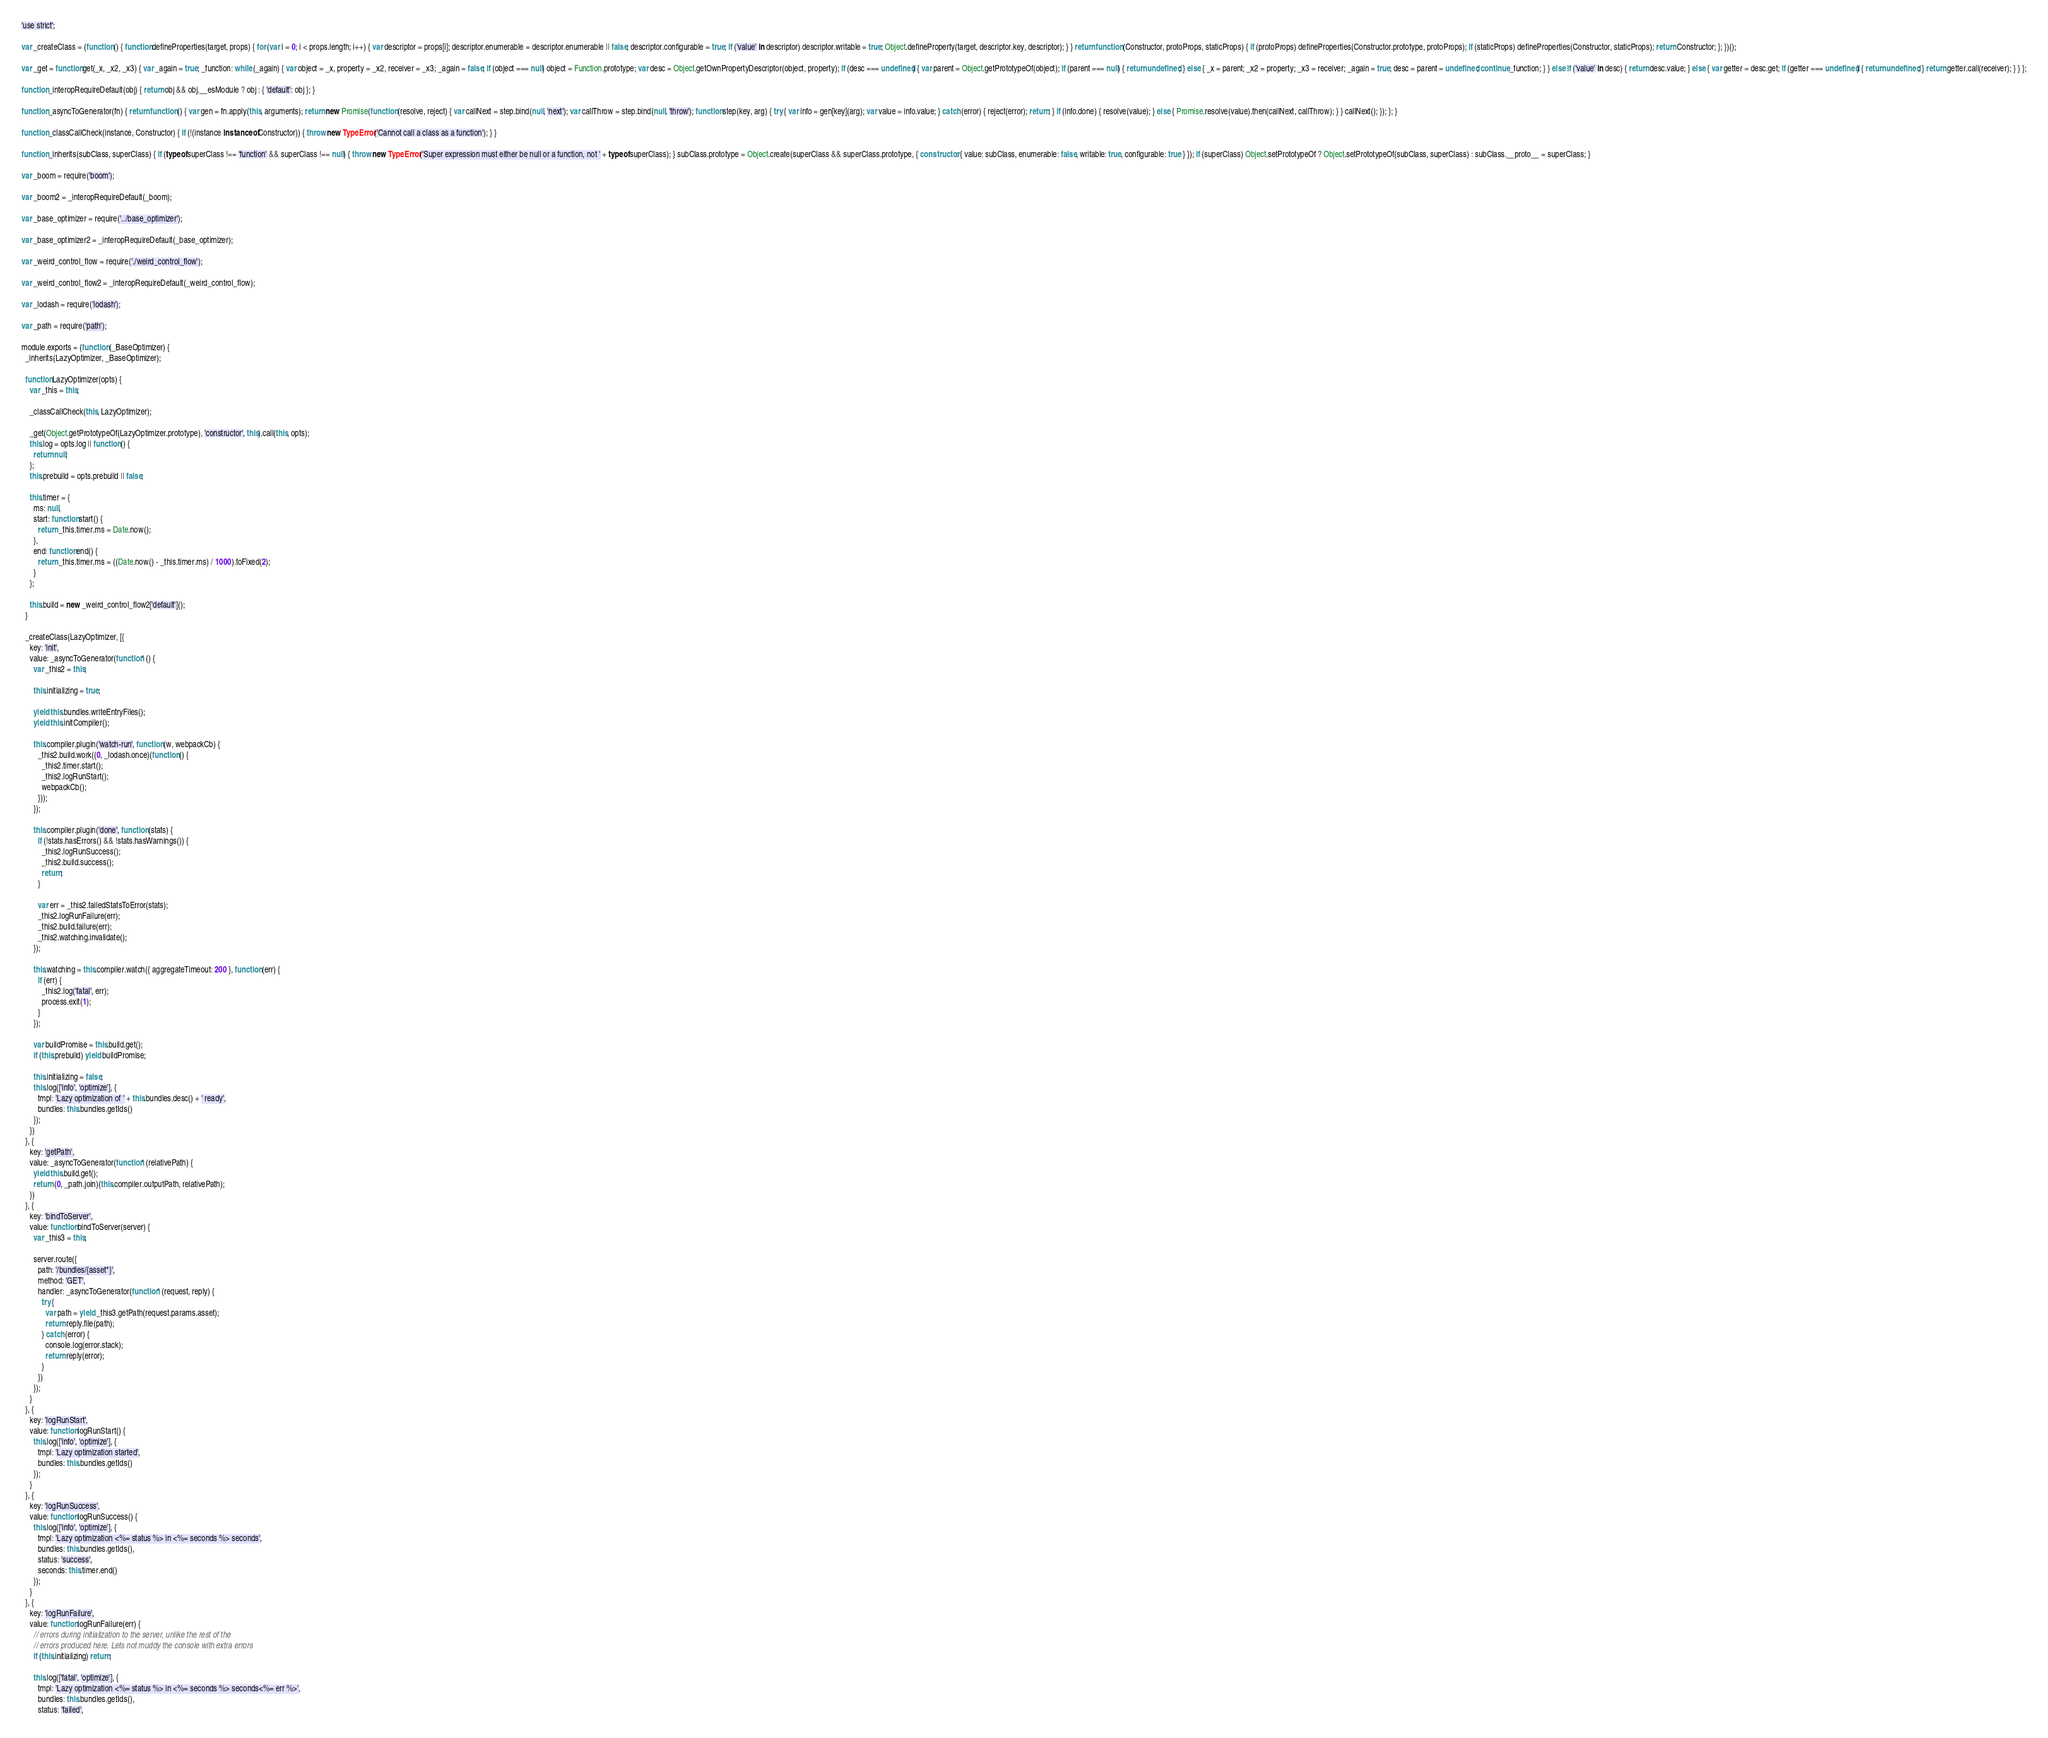<code> <loc_0><loc_0><loc_500><loc_500><_JavaScript_>'use strict';

var _createClass = (function () { function defineProperties(target, props) { for (var i = 0; i < props.length; i++) { var descriptor = props[i]; descriptor.enumerable = descriptor.enumerable || false; descriptor.configurable = true; if ('value' in descriptor) descriptor.writable = true; Object.defineProperty(target, descriptor.key, descriptor); } } return function (Constructor, protoProps, staticProps) { if (protoProps) defineProperties(Constructor.prototype, protoProps); if (staticProps) defineProperties(Constructor, staticProps); return Constructor; }; })();

var _get = function get(_x, _x2, _x3) { var _again = true; _function: while (_again) { var object = _x, property = _x2, receiver = _x3; _again = false; if (object === null) object = Function.prototype; var desc = Object.getOwnPropertyDescriptor(object, property); if (desc === undefined) { var parent = Object.getPrototypeOf(object); if (parent === null) { return undefined; } else { _x = parent; _x2 = property; _x3 = receiver; _again = true; desc = parent = undefined; continue _function; } } else if ('value' in desc) { return desc.value; } else { var getter = desc.get; if (getter === undefined) { return undefined; } return getter.call(receiver); } } };

function _interopRequireDefault(obj) { return obj && obj.__esModule ? obj : { 'default': obj }; }

function _asyncToGenerator(fn) { return function () { var gen = fn.apply(this, arguments); return new Promise(function (resolve, reject) { var callNext = step.bind(null, 'next'); var callThrow = step.bind(null, 'throw'); function step(key, arg) { try { var info = gen[key](arg); var value = info.value; } catch (error) { reject(error); return; } if (info.done) { resolve(value); } else { Promise.resolve(value).then(callNext, callThrow); } } callNext(); }); }; }

function _classCallCheck(instance, Constructor) { if (!(instance instanceof Constructor)) { throw new TypeError('Cannot call a class as a function'); } }

function _inherits(subClass, superClass) { if (typeof superClass !== 'function' && superClass !== null) { throw new TypeError('Super expression must either be null or a function, not ' + typeof superClass); } subClass.prototype = Object.create(superClass && superClass.prototype, { constructor: { value: subClass, enumerable: false, writable: true, configurable: true } }); if (superClass) Object.setPrototypeOf ? Object.setPrototypeOf(subClass, superClass) : subClass.__proto__ = superClass; }

var _boom = require('boom');

var _boom2 = _interopRequireDefault(_boom);

var _base_optimizer = require('../base_optimizer');

var _base_optimizer2 = _interopRequireDefault(_base_optimizer);

var _weird_control_flow = require('./weird_control_flow');

var _weird_control_flow2 = _interopRequireDefault(_weird_control_flow);

var _lodash = require('lodash');

var _path = require('path');

module.exports = (function (_BaseOptimizer) {
  _inherits(LazyOptimizer, _BaseOptimizer);

  function LazyOptimizer(opts) {
    var _this = this;

    _classCallCheck(this, LazyOptimizer);

    _get(Object.getPrototypeOf(LazyOptimizer.prototype), 'constructor', this).call(this, opts);
    this.log = opts.log || function () {
      return null;
    };
    this.prebuild = opts.prebuild || false;

    this.timer = {
      ms: null,
      start: function start() {
        return _this.timer.ms = Date.now();
      },
      end: function end() {
        return _this.timer.ms = ((Date.now() - _this.timer.ms) / 1000).toFixed(2);
      }
    };

    this.build = new _weird_control_flow2['default']();
  }

  _createClass(LazyOptimizer, [{
    key: 'init',
    value: _asyncToGenerator(function* () {
      var _this2 = this;

      this.initializing = true;

      yield this.bundles.writeEntryFiles();
      yield this.initCompiler();

      this.compiler.plugin('watch-run', function (w, webpackCb) {
        _this2.build.work((0, _lodash.once)(function () {
          _this2.timer.start();
          _this2.logRunStart();
          webpackCb();
        }));
      });

      this.compiler.plugin('done', function (stats) {
        if (!stats.hasErrors() && !stats.hasWarnings()) {
          _this2.logRunSuccess();
          _this2.build.success();
          return;
        }

        var err = _this2.failedStatsToError(stats);
        _this2.logRunFailure(err);
        _this2.build.failure(err);
        _this2.watching.invalidate();
      });

      this.watching = this.compiler.watch({ aggregateTimeout: 200 }, function (err) {
        if (err) {
          _this2.log('fatal', err);
          process.exit(1);
        }
      });

      var buildPromise = this.build.get();
      if (this.prebuild) yield buildPromise;

      this.initializing = false;
      this.log(['info', 'optimize'], {
        tmpl: 'Lazy optimization of ' + this.bundles.desc() + ' ready',
        bundles: this.bundles.getIds()
      });
    })
  }, {
    key: 'getPath',
    value: _asyncToGenerator(function* (relativePath) {
      yield this.build.get();
      return (0, _path.join)(this.compiler.outputPath, relativePath);
    })
  }, {
    key: 'bindToServer',
    value: function bindToServer(server) {
      var _this3 = this;

      server.route({
        path: '/bundles/{asset*}',
        method: 'GET',
        handler: _asyncToGenerator(function* (request, reply) {
          try {
            var path = yield _this3.getPath(request.params.asset);
            return reply.file(path);
          } catch (error) {
            console.log(error.stack);
            return reply(error);
          }
        })
      });
    }
  }, {
    key: 'logRunStart',
    value: function logRunStart() {
      this.log(['info', 'optimize'], {
        tmpl: 'Lazy optimization started',
        bundles: this.bundles.getIds()
      });
    }
  }, {
    key: 'logRunSuccess',
    value: function logRunSuccess() {
      this.log(['info', 'optimize'], {
        tmpl: 'Lazy optimization <%= status %> in <%= seconds %> seconds',
        bundles: this.bundles.getIds(),
        status: 'success',
        seconds: this.timer.end()
      });
    }
  }, {
    key: 'logRunFailure',
    value: function logRunFailure(err) {
      // errors during initialization to the server, unlike the rest of the
      // errors produced here. Lets not muddy the console with extra errors
      if (this.initializing) return;

      this.log(['fatal', 'optimize'], {
        tmpl: 'Lazy optimization <%= status %> in <%= seconds %> seconds<%= err %>',
        bundles: this.bundles.getIds(),
        status: 'failed',</code> 